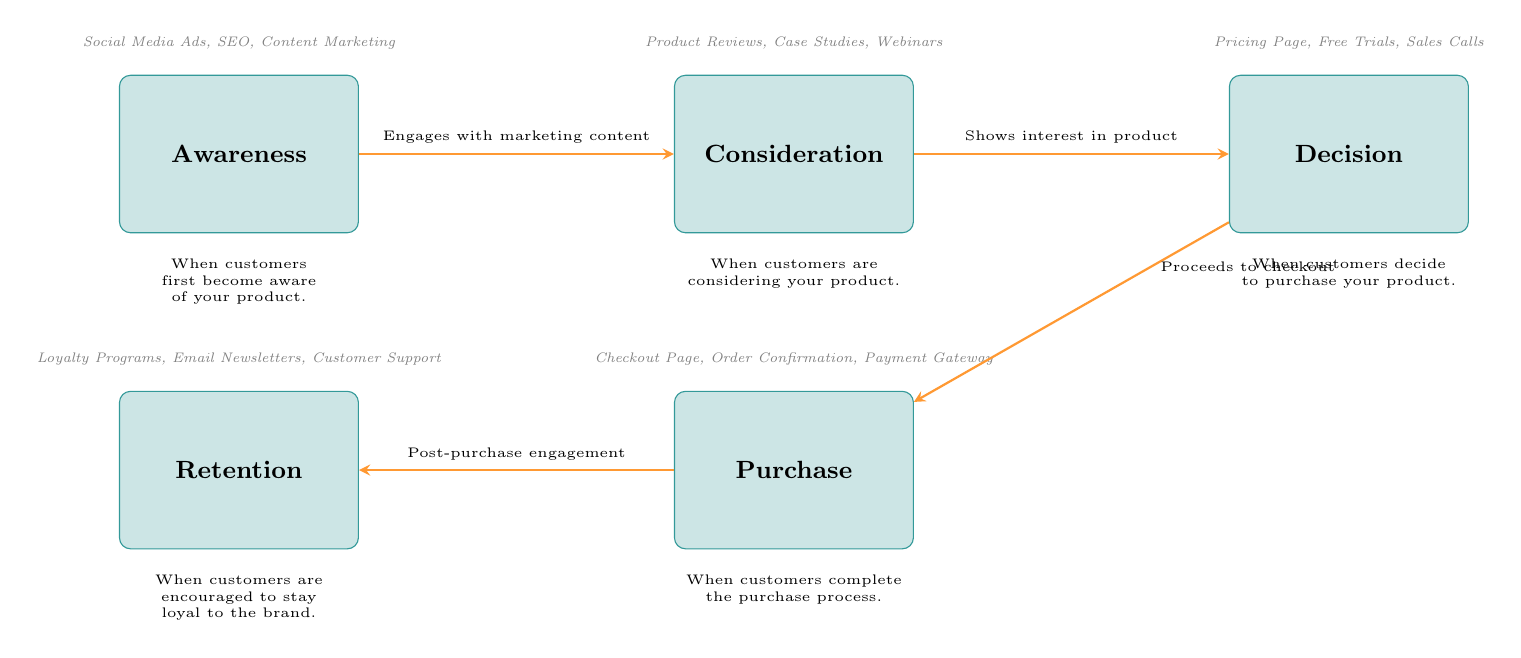What are the names of the five stages in the customer journey? The diagram lists the stages of the customer journey as Awareness, Consideration, Decision, Purchase, and Retention.
Answer: Awareness, Consideration, Decision, Purchase, Retention Which stage is associated with post-purchase engagement? According to the diagram, the stage that involves post-purchase engagement is Retention.
Answer: Retention What type of content engages customers in the Awareness stage? The diagram shows that the types of content engaging customers in the Awareness stage include Social Media Ads, SEO, and Content Marketing.
Answer: Social Media Ads, SEO, Content Marketing What comes after the Decision stage in the customer journey? The flow in the diagram indicates that the stage following Decision is Purchase.
Answer: Purchase How many examples are provided for the Purchase stage? The diagram contains three examples listed for the Purchase stage: Checkout Page, Order Confirmation, and Payment Gateway. Therefore, the answer is three.
Answer: Three What do customers show interest in during the Consideration stage? The diagram states that during the Consideration stage, customers show interest in the product.
Answer: Interest in the product What is the labeled action that occurs between Consideration and Decision stages? The diagram labels the action that occurs between the Consideration and Decision stages as "Shows interest in product."
Answer: Shows interest in product Which marketing strategies are suggested for the Retention stage? Customers are encouraged to stay loyal through strategies like Loyalty Programs, Email Newsletters, and Customer Support, as indicated in the diagram.
Answer: Loyalty Programs, Email Newsletters, Customer Support How many arrows are drawn in total in the diagram? The diagram illustrates four arrows connecting the stages, representing the flow of the customer journey.
Answer: Four 